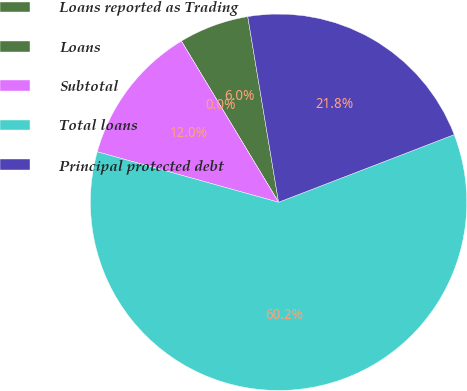Convert chart to OTSL. <chart><loc_0><loc_0><loc_500><loc_500><pie_chart><fcel>Loans reported as Trading<fcel>Loans<fcel>Subtotal<fcel>Total loans<fcel>Principal protected debt<nl><fcel>6.02%<fcel>0.0%<fcel>12.04%<fcel>60.17%<fcel>21.77%<nl></chart> 